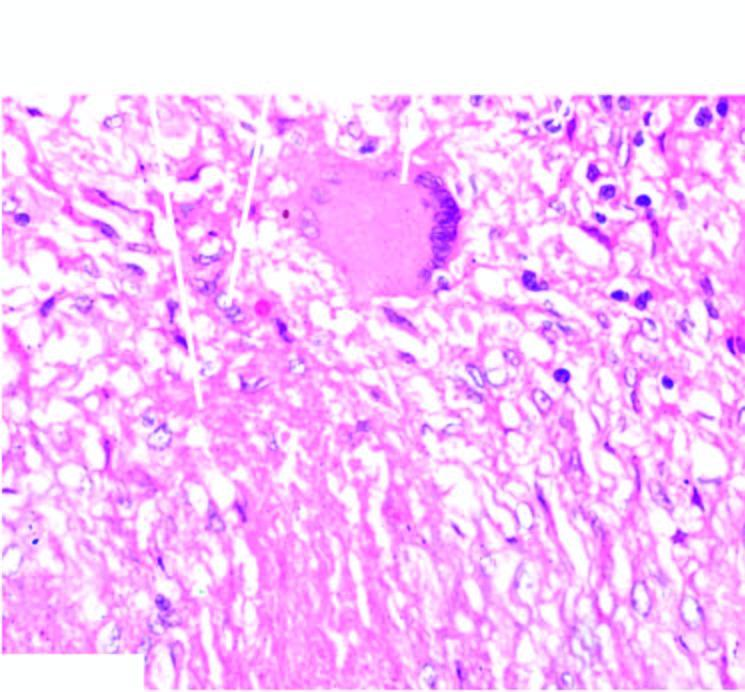what is central caseation necrosis surrounded by?
Answer the question using a single word or phrase. Elongated epithelioid cells having characteristic slipper-shaped nuclei 